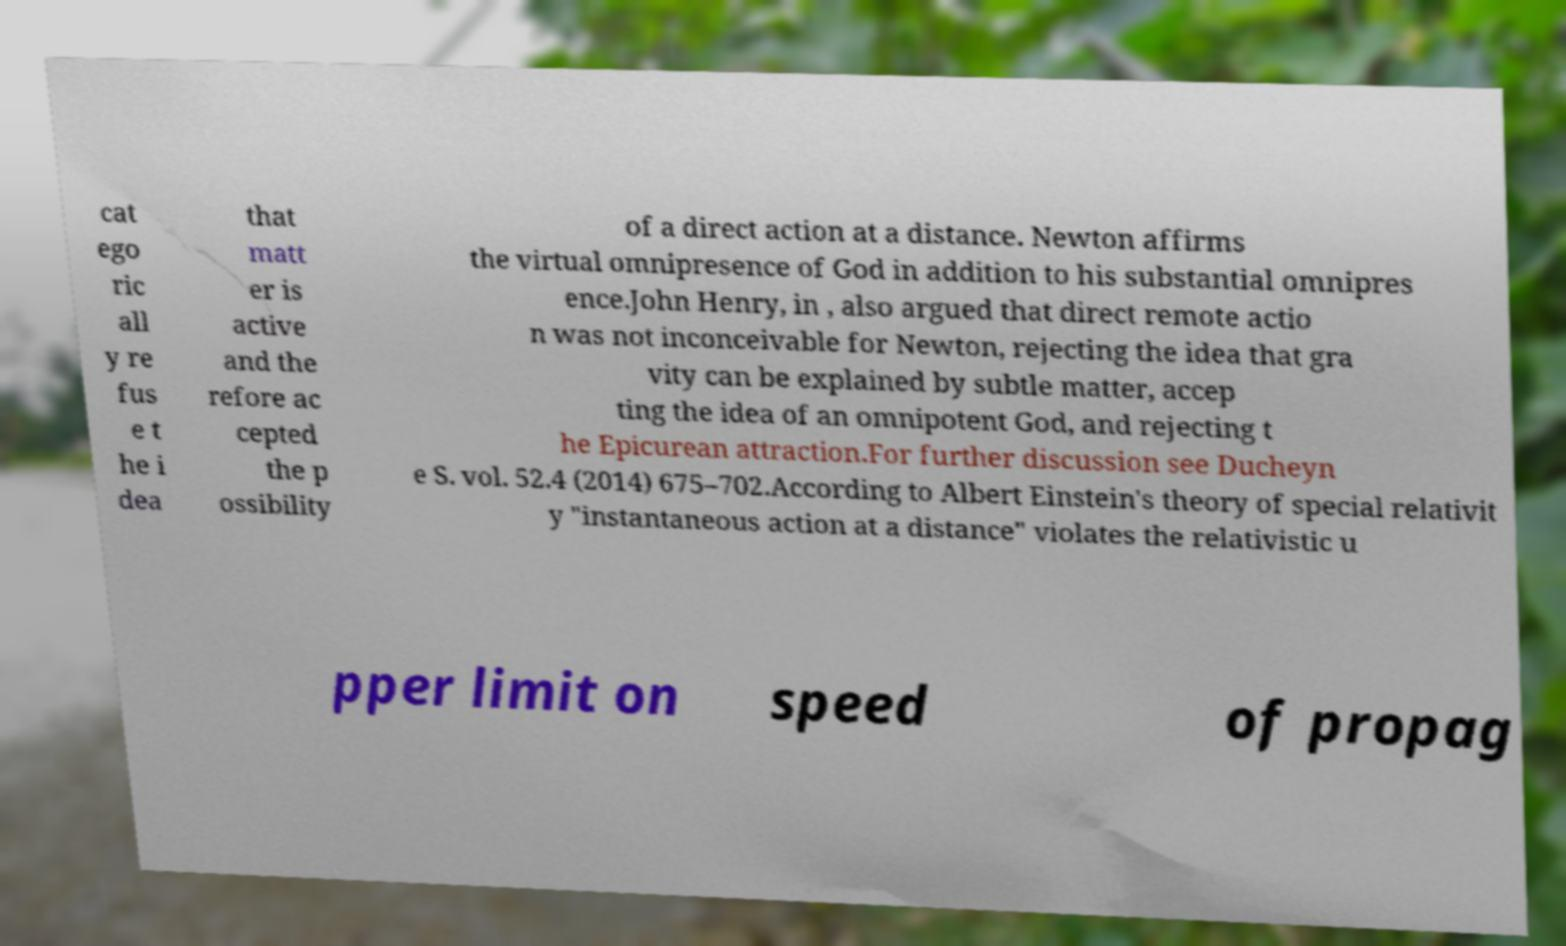For documentation purposes, I need the text within this image transcribed. Could you provide that? cat ego ric all y re fus e t he i dea that matt er is active and the refore ac cepted the p ossibility of a direct action at a distance. Newton affirms the virtual omnipresence of God in addition to his substantial omnipres ence.John Henry, in , also argued that direct remote actio n was not inconceivable for Newton, rejecting the idea that gra vity can be explained by subtle matter, accep ting the idea of an omnipotent God, and rejecting t he Epicurean attraction.For further discussion see Ducheyn e S. vol. 52.4 (2014) 675–702.According to Albert Einstein's theory of special relativit y "instantaneous action at a distance" violates the relativistic u pper limit on speed of propag 